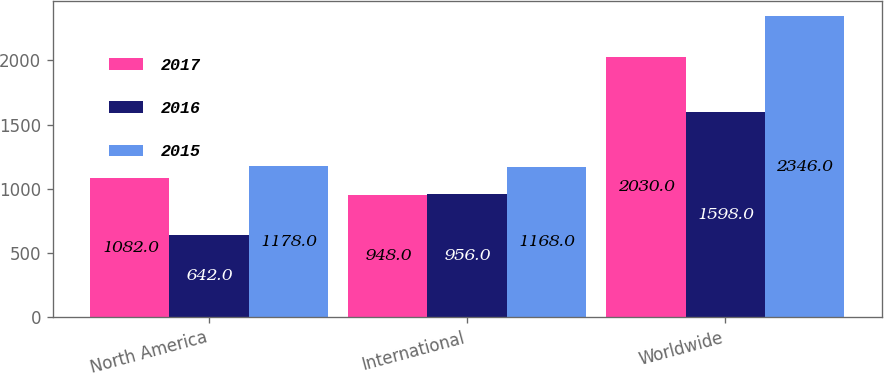Convert chart to OTSL. <chart><loc_0><loc_0><loc_500><loc_500><stacked_bar_chart><ecel><fcel>North America<fcel>International<fcel>Worldwide<nl><fcel>2017<fcel>1082<fcel>948<fcel>2030<nl><fcel>2016<fcel>642<fcel>956<fcel>1598<nl><fcel>2015<fcel>1178<fcel>1168<fcel>2346<nl></chart> 